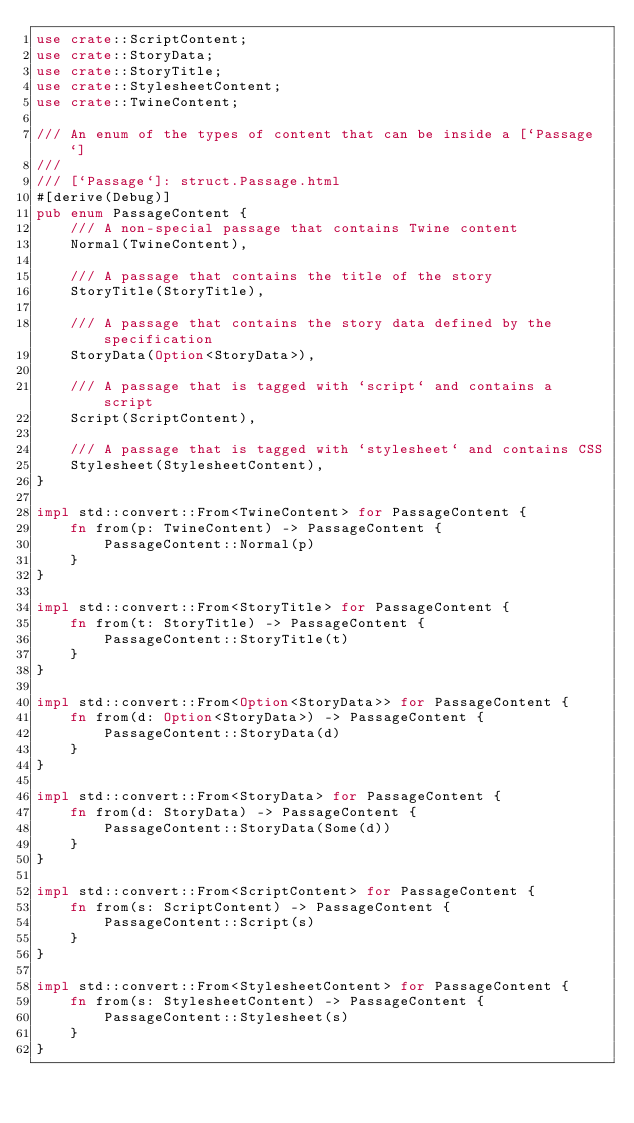Convert code to text. <code><loc_0><loc_0><loc_500><loc_500><_Rust_>use crate::ScriptContent;
use crate::StoryData;
use crate::StoryTitle;
use crate::StylesheetContent;
use crate::TwineContent;

/// An enum of the types of content that can be inside a [`Passage`]
///
/// [`Passage`]: struct.Passage.html
#[derive(Debug)]
pub enum PassageContent {
    /// A non-special passage that contains Twine content
    Normal(TwineContent),

    /// A passage that contains the title of the story
    StoryTitle(StoryTitle),

    /// A passage that contains the story data defined by the specification
    StoryData(Option<StoryData>),

    /// A passage that is tagged with `script` and contains a script
    Script(ScriptContent),

    /// A passage that is tagged with `stylesheet` and contains CSS
    Stylesheet(StylesheetContent),
}

impl std::convert::From<TwineContent> for PassageContent {
    fn from(p: TwineContent) -> PassageContent {
        PassageContent::Normal(p)
    }
}

impl std::convert::From<StoryTitle> for PassageContent {
    fn from(t: StoryTitle) -> PassageContent {
        PassageContent::StoryTitle(t)
    }
}

impl std::convert::From<Option<StoryData>> for PassageContent {
    fn from(d: Option<StoryData>) -> PassageContent {
        PassageContent::StoryData(d)
    }
}

impl std::convert::From<StoryData> for PassageContent {
    fn from(d: StoryData) -> PassageContent {
        PassageContent::StoryData(Some(d))
    }
}

impl std::convert::From<ScriptContent> for PassageContent {
    fn from(s: ScriptContent) -> PassageContent {
        PassageContent::Script(s)
    }
}

impl std::convert::From<StylesheetContent> for PassageContent {
    fn from(s: StylesheetContent) -> PassageContent {
        PassageContent::Stylesheet(s)
    }
}
</code> 